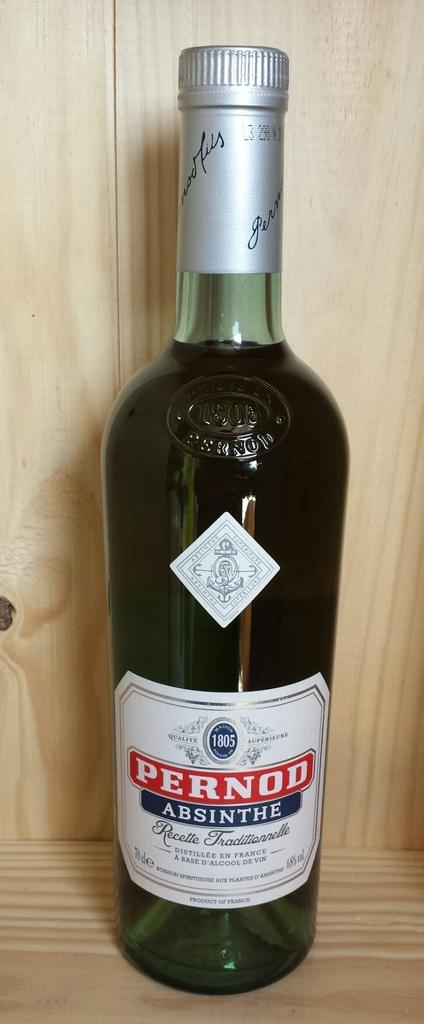<image>
Give a short and clear explanation of the subsequent image. A unopened bottle of Pernod Absinthe is on a wooden display. 